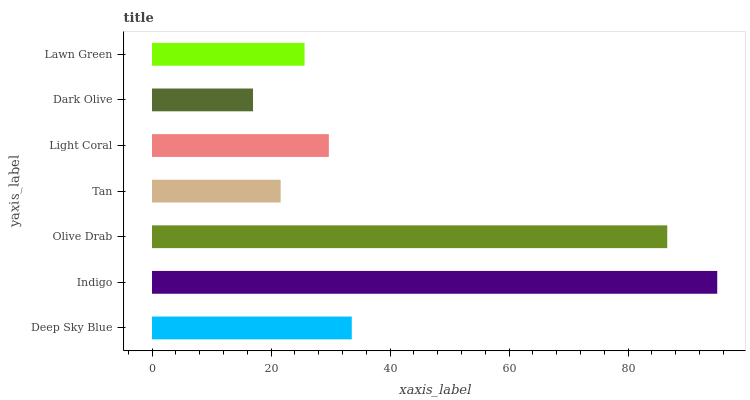Is Dark Olive the minimum?
Answer yes or no. Yes. Is Indigo the maximum?
Answer yes or no. Yes. Is Olive Drab the minimum?
Answer yes or no. No. Is Olive Drab the maximum?
Answer yes or no. No. Is Indigo greater than Olive Drab?
Answer yes or no. Yes. Is Olive Drab less than Indigo?
Answer yes or no. Yes. Is Olive Drab greater than Indigo?
Answer yes or no. No. Is Indigo less than Olive Drab?
Answer yes or no. No. Is Light Coral the high median?
Answer yes or no. Yes. Is Light Coral the low median?
Answer yes or no. Yes. Is Tan the high median?
Answer yes or no. No. Is Indigo the low median?
Answer yes or no. No. 